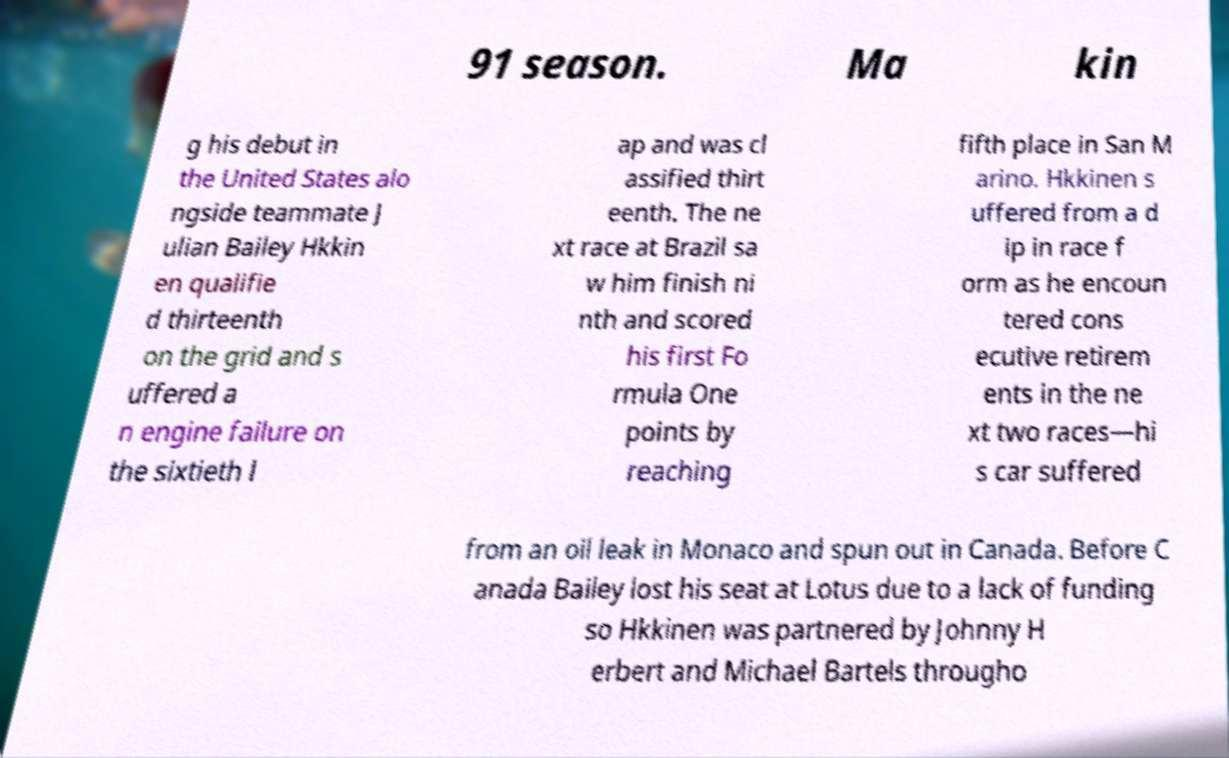Could you assist in decoding the text presented in this image and type it out clearly? 91 season. Ma kin g his debut in the United States alo ngside teammate J ulian Bailey Hkkin en qualifie d thirteenth on the grid and s uffered a n engine failure on the sixtieth l ap and was cl assified thirt eenth. The ne xt race at Brazil sa w him finish ni nth and scored his first Fo rmula One points by reaching fifth place in San M arino. Hkkinen s uffered from a d ip in race f orm as he encoun tered cons ecutive retirem ents in the ne xt two races—hi s car suffered from an oil leak in Monaco and spun out in Canada. Before C anada Bailey lost his seat at Lotus due to a lack of funding so Hkkinen was partnered by Johnny H erbert and Michael Bartels througho 